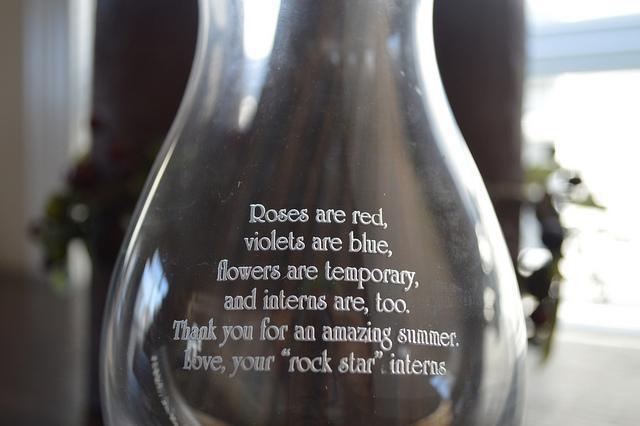How many vases can you see?
Give a very brief answer. 2. How many bowls are pictured?
Give a very brief answer. 0. 